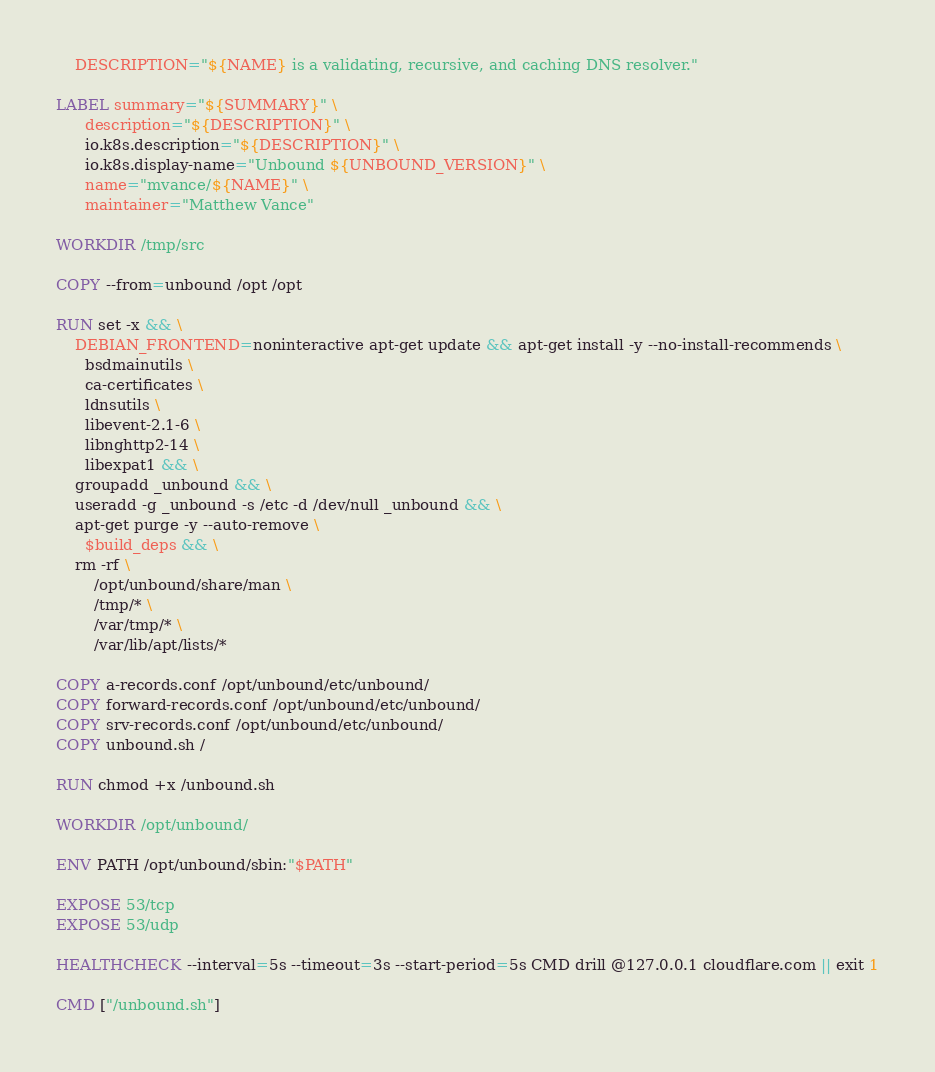Convert code to text. <code><loc_0><loc_0><loc_500><loc_500><_Dockerfile_>    DESCRIPTION="${NAME} is a validating, recursive, and caching DNS resolver."

LABEL summary="${SUMMARY}" \
      description="${DESCRIPTION}" \
      io.k8s.description="${DESCRIPTION}" \
      io.k8s.display-name="Unbound ${UNBOUND_VERSION}" \
      name="mvance/${NAME}" \
      maintainer="Matthew Vance"

WORKDIR /tmp/src

COPY --from=unbound /opt /opt

RUN set -x && \
    DEBIAN_FRONTEND=noninteractive apt-get update && apt-get install -y --no-install-recommends \
      bsdmainutils \
      ca-certificates \
      ldnsutils \
      libevent-2.1-6 \
      libnghttp2-14 \
      libexpat1 && \
    groupadd _unbound && \
    useradd -g _unbound -s /etc -d /dev/null _unbound && \
    apt-get purge -y --auto-remove \
      $build_deps && \
    rm -rf \
        /opt/unbound/share/man \
        /tmp/* \
        /var/tmp/* \
        /var/lib/apt/lists/*

COPY a-records.conf /opt/unbound/etc/unbound/
COPY forward-records.conf /opt/unbound/etc/unbound/
COPY srv-records.conf /opt/unbound/etc/unbound/
COPY unbound.sh /

RUN chmod +x /unbound.sh

WORKDIR /opt/unbound/

ENV PATH /opt/unbound/sbin:"$PATH"

EXPOSE 53/tcp
EXPOSE 53/udp

HEALTHCHECK --interval=5s --timeout=3s --start-period=5s CMD drill @127.0.0.1 cloudflare.com || exit 1

CMD ["/unbound.sh"]
</code> 